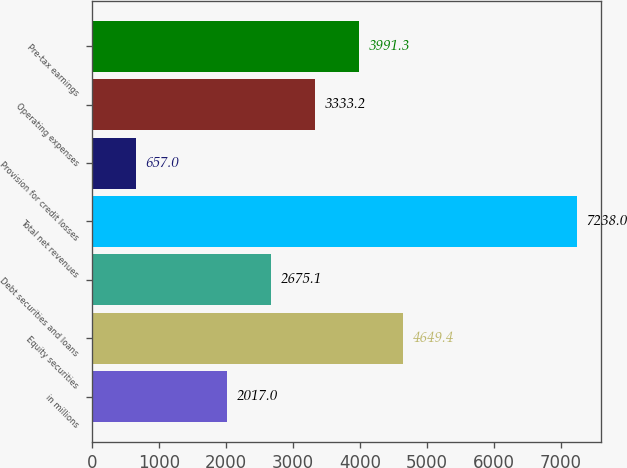<chart> <loc_0><loc_0><loc_500><loc_500><bar_chart><fcel>in millions<fcel>Equity securities<fcel>Debt securities and loans<fcel>Total net revenues<fcel>Provision for credit losses<fcel>Operating expenses<fcel>Pre-tax earnings<nl><fcel>2017<fcel>4649.4<fcel>2675.1<fcel>7238<fcel>657<fcel>3333.2<fcel>3991.3<nl></chart> 